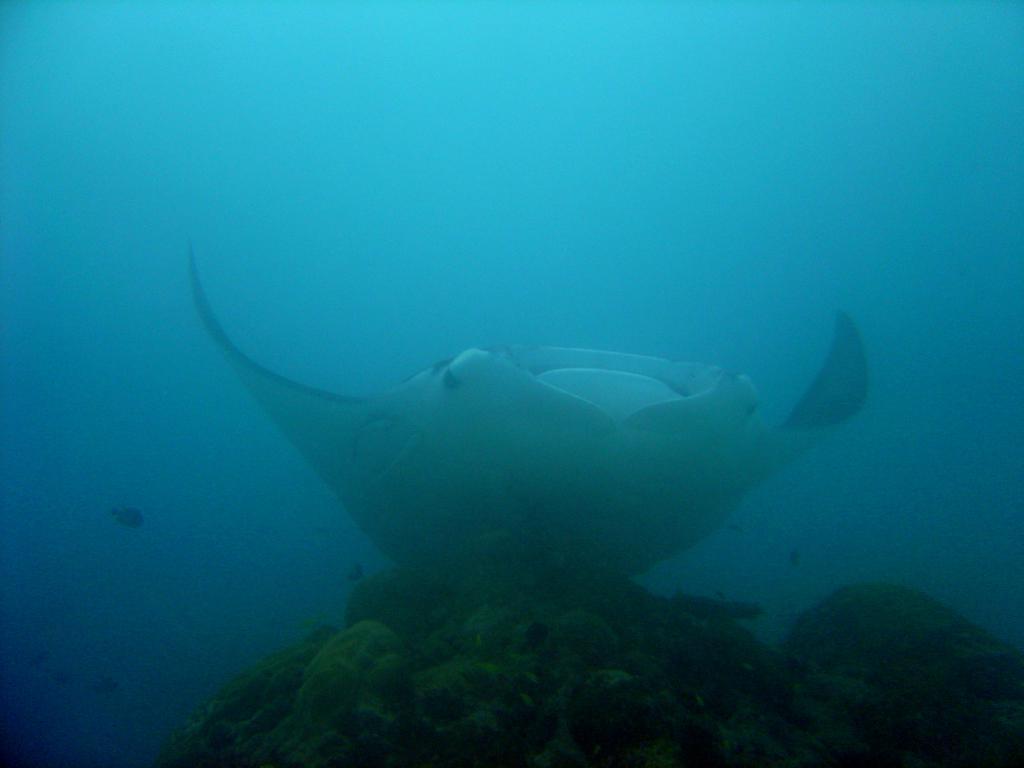Describe this image in one or two sentences. This image is taken in the sea. In the middle of the image there is a fish in the water. At the bottom of the image there are a few coral reefs in the sea. 